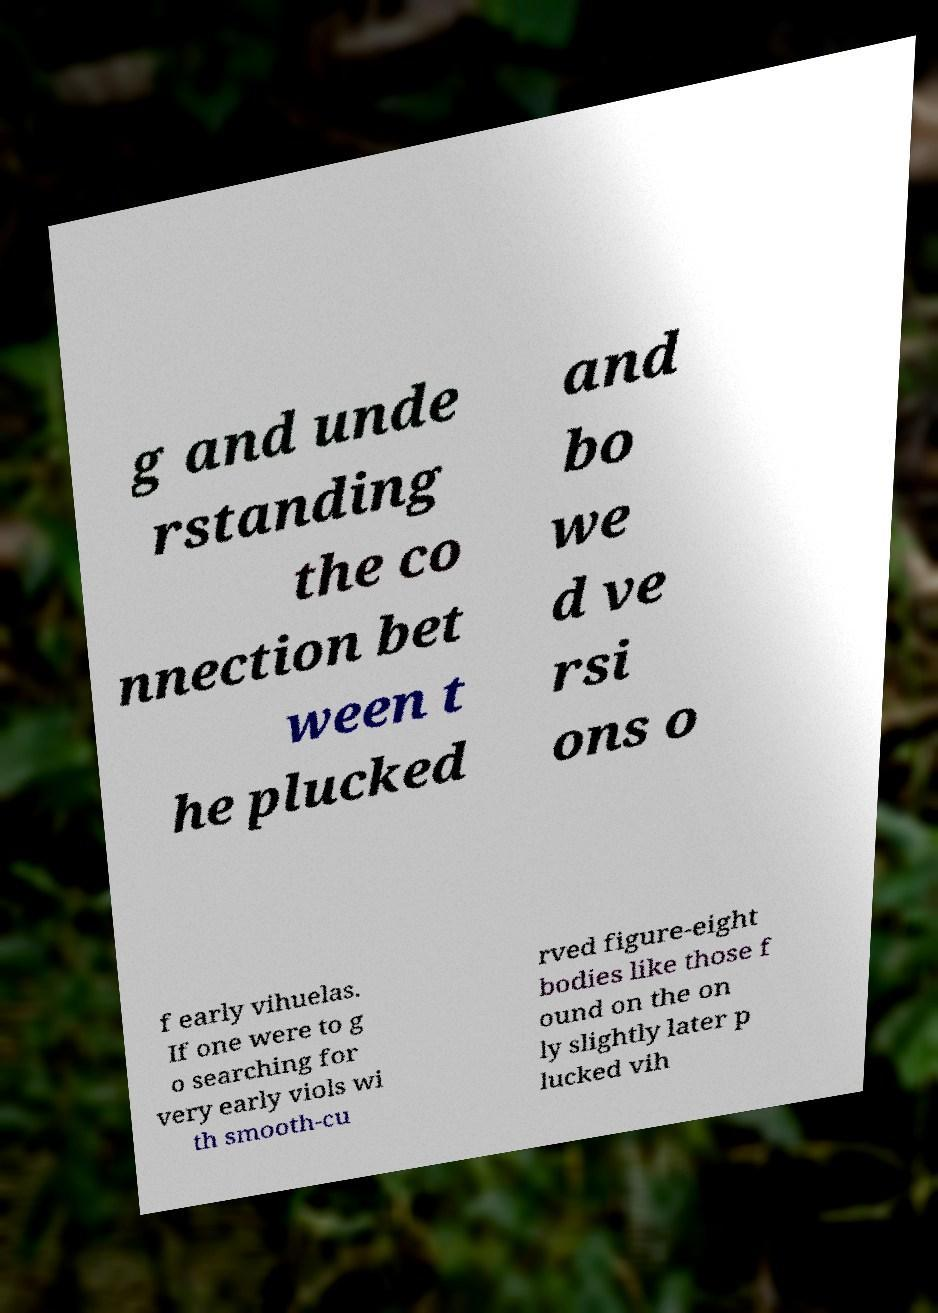Could you assist in decoding the text presented in this image and type it out clearly? g and unde rstanding the co nnection bet ween t he plucked and bo we d ve rsi ons o f early vihuelas. If one were to g o searching for very early viols wi th smooth-cu rved figure-eight bodies like those f ound on the on ly slightly later p lucked vih 